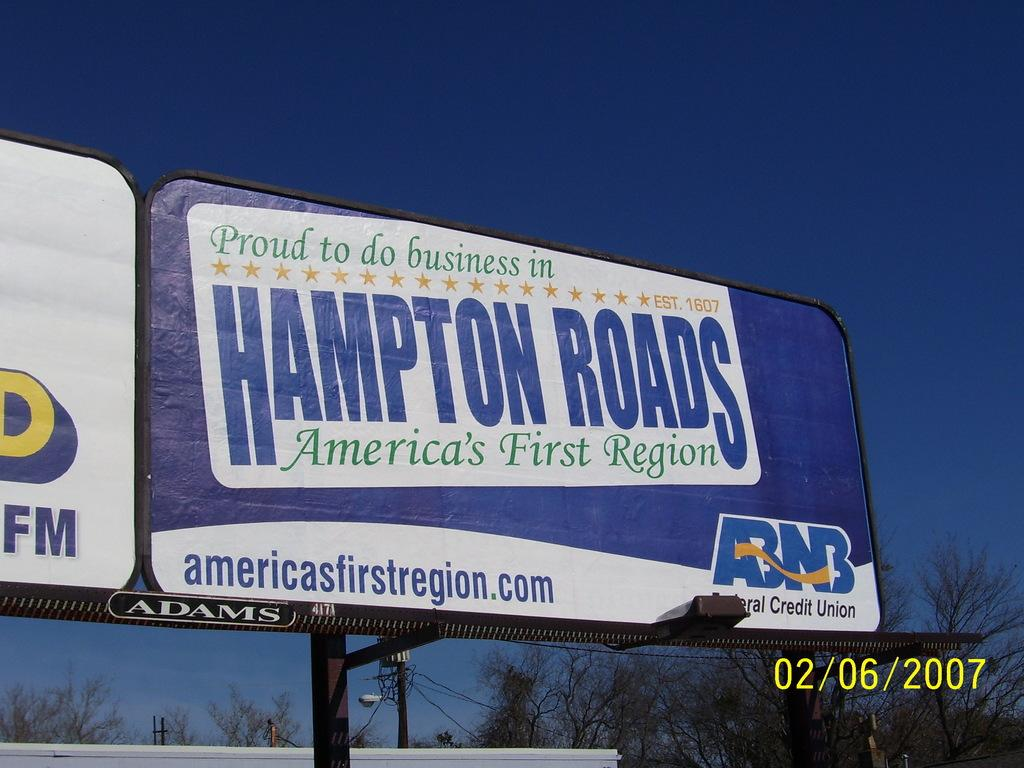<image>
Create a compact narrative representing the image presented. a billboard that says 'proud to do business in hampton roads america's first region' 